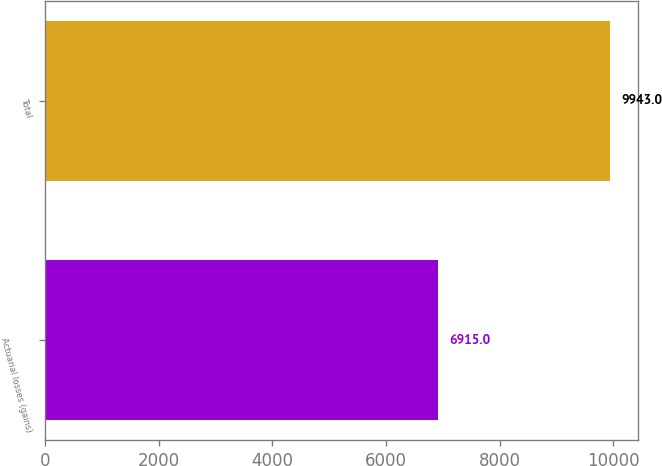Convert chart. <chart><loc_0><loc_0><loc_500><loc_500><bar_chart><fcel>Actuarial losses (gains)<fcel>Total<nl><fcel>6915<fcel>9943<nl></chart> 